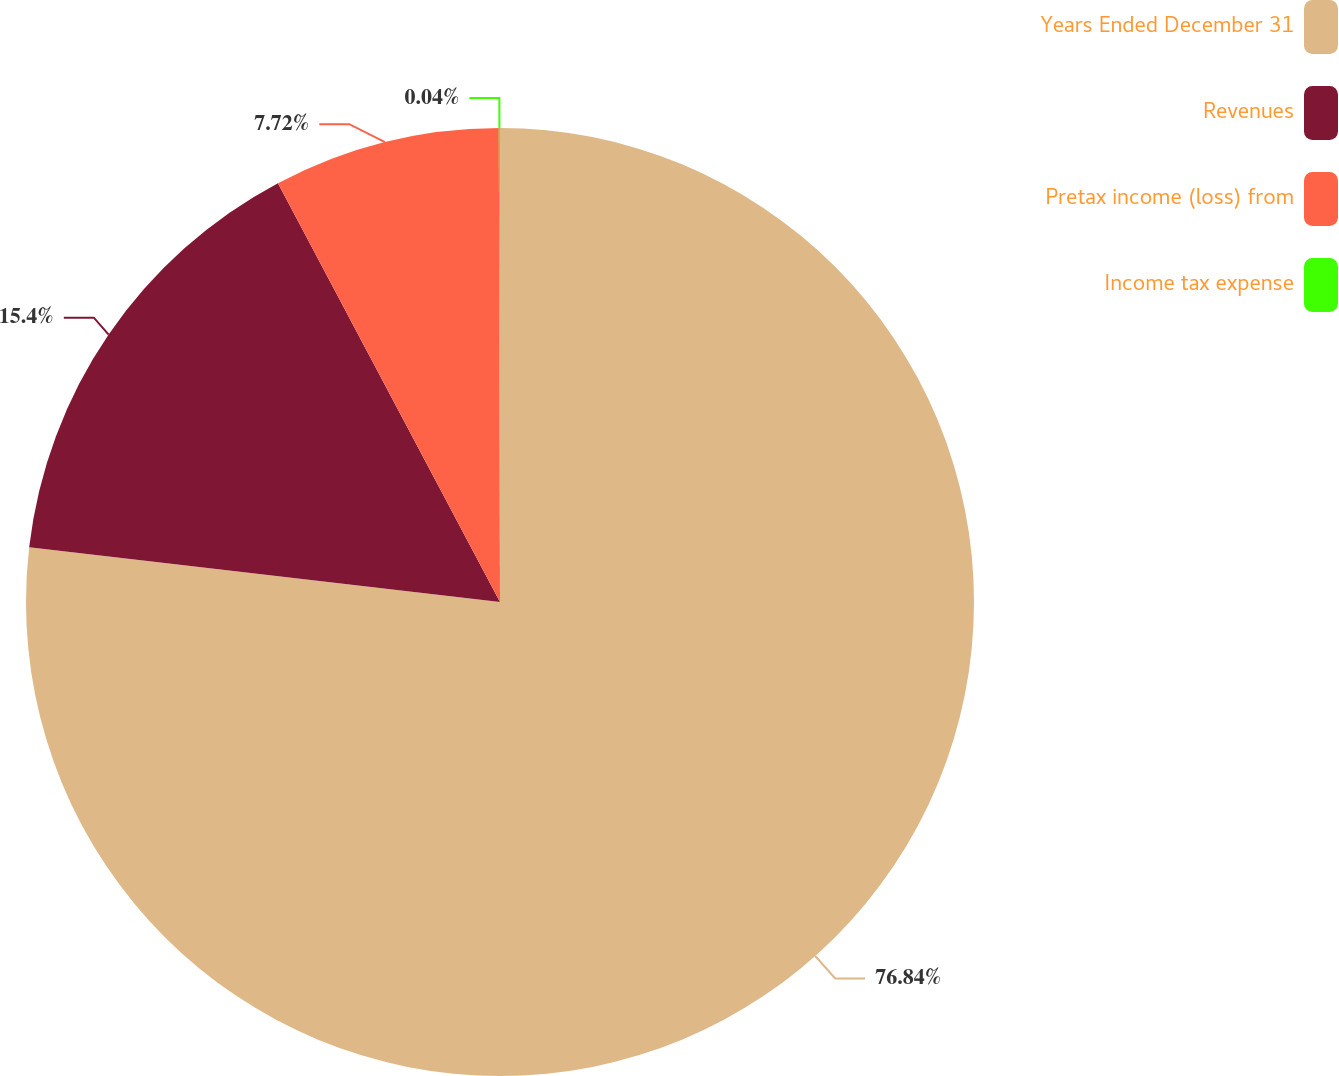<chart> <loc_0><loc_0><loc_500><loc_500><pie_chart><fcel>Years Ended December 31<fcel>Revenues<fcel>Pretax income (loss) from<fcel>Income tax expense<nl><fcel>76.84%<fcel>15.4%<fcel>7.72%<fcel>0.04%<nl></chart> 